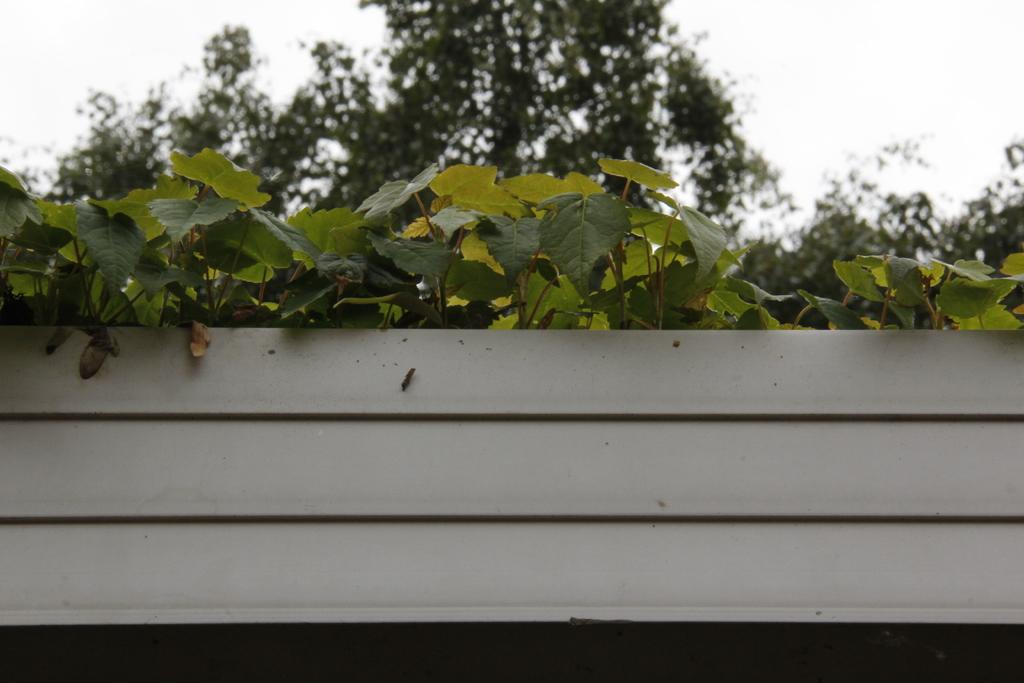What is placed on the rack in the image? There are plants in a rack in the image. What can be seen in the background of the image? There are trees and the sky visible in the background of the image. What message is being conveyed in the advertisement in the image? There is no advertisement present in the image; it features plants in a rack and trees in the background. 